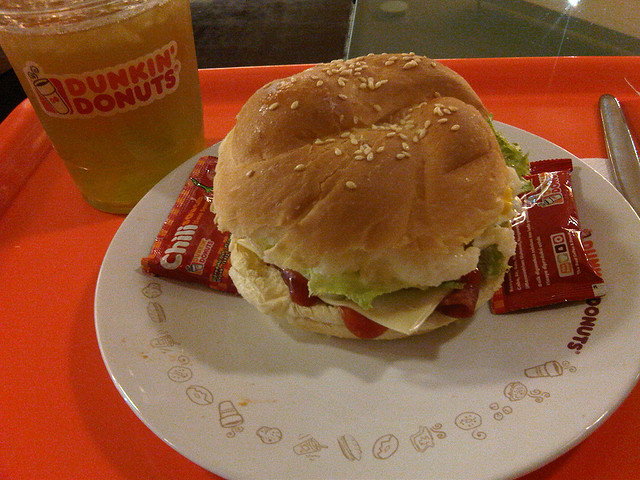Read and extract the text from this image. DUNKIN' Dunkin' Donuts Chili DONUTS DIM 